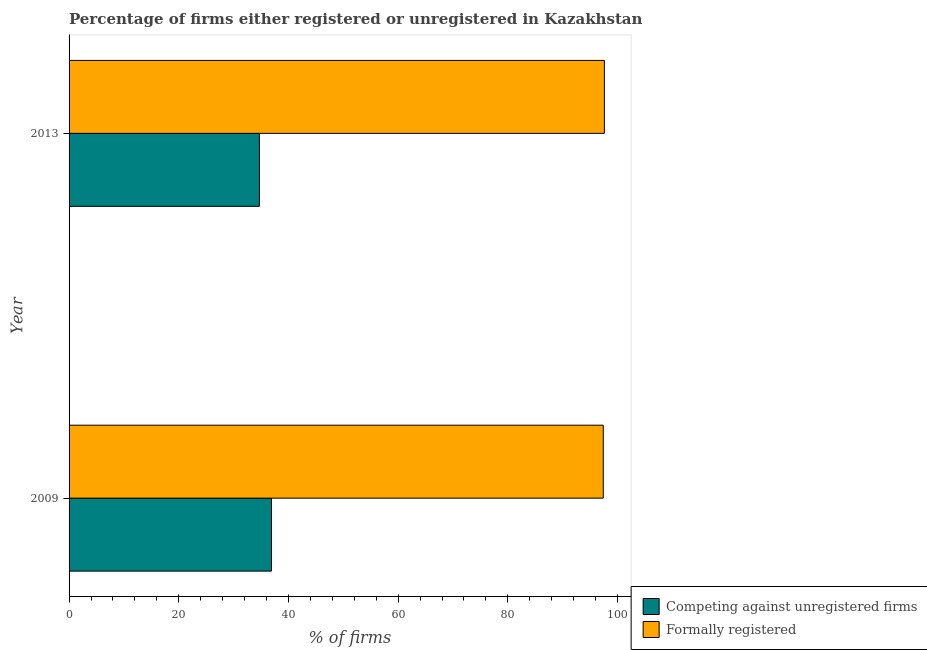How many different coloured bars are there?
Offer a terse response. 2. How many groups of bars are there?
Give a very brief answer. 2. How many bars are there on the 1st tick from the top?
Offer a very short reply. 2. What is the percentage of registered firms in 2013?
Provide a short and direct response. 34.7. Across all years, what is the maximum percentage of registered firms?
Keep it short and to the point. 36.9. Across all years, what is the minimum percentage of registered firms?
Provide a short and direct response. 34.7. In which year was the percentage of formally registered firms maximum?
Offer a terse response. 2013. In which year was the percentage of registered firms minimum?
Your answer should be very brief. 2013. What is the total percentage of formally registered firms in the graph?
Offer a very short reply. 195. What is the difference between the percentage of registered firms in 2009 and that in 2013?
Make the answer very short. 2.2. What is the difference between the percentage of registered firms in 2009 and the percentage of formally registered firms in 2013?
Provide a short and direct response. -60.7. What is the average percentage of registered firms per year?
Your response must be concise. 35.8. In the year 2009, what is the difference between the percentage of formally registered firms and percentage of registered firms?
Your response must be concise. 60.5. What does the 1st bar from the top in 2009 represents?
Provide a succinct answer. Formally registered. What does the 2nd bar from the bottom in 2009 represents?
Keep it short and to the point. Formally registered. What is the difference between two consecutive major ticks on the X-axis?
Make the answer very short. 20. Does the graph contain grids?
Offer a very short reply. No. Where does the legend appear in the graph?
Ensure brevity in your answer.  Bottom right. How many legend labels are there?
Keep it short and to the point. 2. How are the legend labels stacked?
Give a very brief answer. Vertical. What is the title of the graph?
Offer a very short reply. Percentage of firms either registered or unregistered in Kazakhstan. Does "Subsidies" appear as one of the legend labels in the graph?
Keep it short and to the point. No. What is the label or title of the X-axis?
Make the answer very short. % of firms. What is the label or title of the Y-axis?
Give a very brief answer. Year. What is the % of firms in Competing against unregistered firms in 2009?
Ensure brevity in your answer.  36.9. What is the % of firms of Formally registered in 2009?
Ensure brevity in your answer.  97.4. What is the % of firms of Competing against unregistered firms in 2013?
Give a very brief answer. 34.7. What is the % of firms of Formally registered in 2013?
Offer a terse response. 97.6. Across all years, what is the maximum % of firms in Competing against unregistered firms?
Make the answer very short. 36.9. Across all years, what is the maximum % of firms in Formally registered?
Give a very brief answer. 97.6. Across all years, what is the minimum % of firms of Competing against unregistered firms?
Provide a succinct answer. 34.7. Across all years, what is the minimum % of firms of Formally registered?
Provide a succinct answer. 97.4. What is the total % of firms of Competing against unregistered firms in the graph?
Offer a terse response. 71.6. What is the total % of firms in Formally registered in the graph?
Provide a short and direct response. 195. What is the difference between the % of firms of Competing against unregistered firms in 2009 and that in 2013?
Keep it short and to the point. 2.2. What is the difference between the % of firms of Competing against unregistered firms in 2009 and the % of firms of Formally registered in 2013?
Offer a terse response. -60.7. What is the average % of firms in Competing against unregistered firms per year?
Offer a terse response. 35.8. What is the average % of firms of Formally registered per year?
Make the answer very short. 97.5. In the year 2009, what is the difference between the % of firms of Competing against unregistered firms and % of firms of Formally registered?
Provide a succinct answer. -60.5. In the year 2013, what is the difference between the % of firms of Competing against unregistered firms and % of firms of Formally registered?
Keep it short and to the point. -62.9. What is the ratio of the % of firms of Competing against unregistered firms in 2009 to that in 2013?
Offer a very short reply. 1.06. What is the difference between the highest and the second highest % of firms in Competing against unregistered firms?
Your answer should be compact. 2.2. What is the difference between the highest and the second highest % of firms in Formally registered?
Your answer should be compact. 0.2. What is the difference between the highest and the lowest % of firms in Competing against unregistered firms?
Your answer should be very brief. 2.2. What is the difference between the highest and the lowest % of firms of Formally registered?
Give a very brief answer. 0.2. 